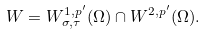<formula> <loc_0><loc_0><loc_500><loc_500>W = W ^ { 1 , p ^ { \prime } } _ { \sigma , \tau } ( \Omega ) \cap W ^ { 2 , p ^ { \prime } } ( \Omega ) .</formula> 